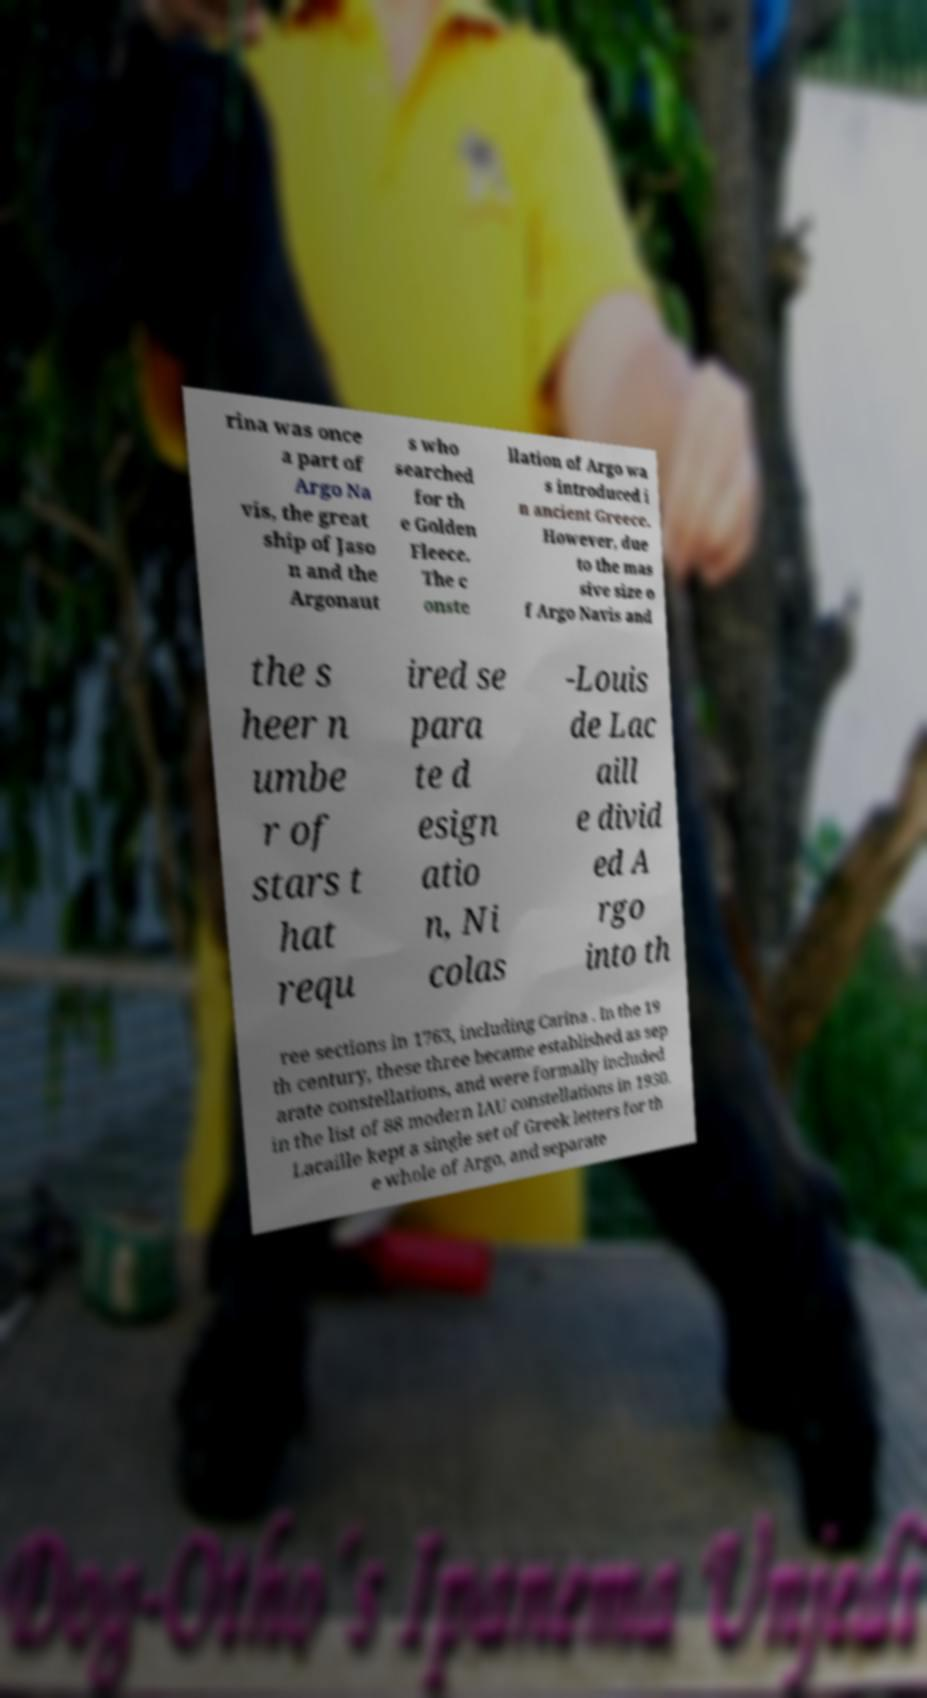There's text embedded in this image that I need extracted. Can you transcribe it verbatim? rina was once a part of Argo Na vis, the great ship of Jaso n and the Argonaut s who searched for th e Golden Fleece. The c onste llation of Argo wa s introduced i n ancient Greece. However, due to the mas sive size o f Argo Navis and the s heer n umbe r of stars t hat requ ired se para te d esign atio n, Ni colas -Louis de Lac aill e divid ed A rgo into th ree sections in 1763, including Carina . In the 19 th century, these three became established as sep arate constellations, and were formally included in the list of 88 modern IAU constellations in 1930. Lacaille kept a single set of Greek letters for th e whole of Argo, and separate 